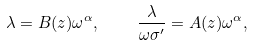Convert formula to latex. <formula><loc_0><loc_0><loc_500><loc_500>\lambda = B ( z ) \omega ^ { \alpha } , \quad \frac { \lambda } { \omega \sigma ^ { \prime } } = A ( z ) \omega ^ { \alpha } ,</formula> 